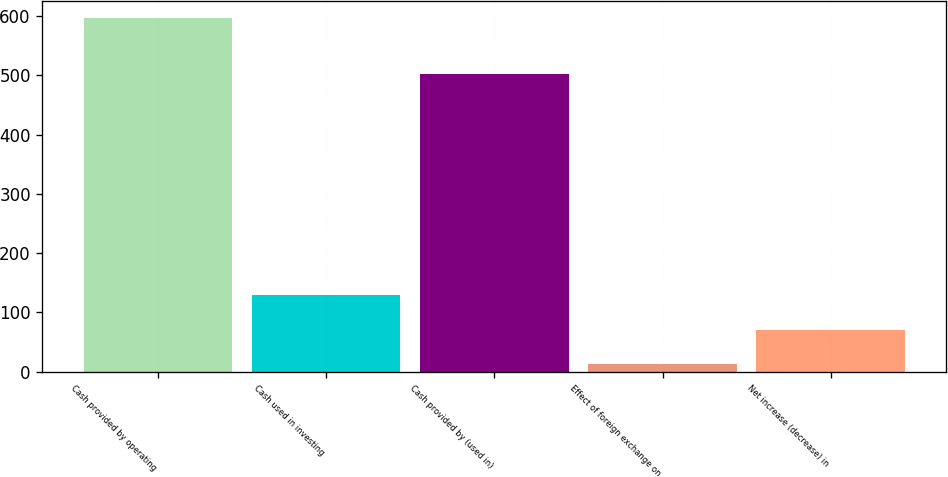Convert chart to OTSL. <chart><loc_0><loc_0><loc_500><loc_500><bar_chart><fcel>Cash provided by operating<fcel>Cash used in investing<fcel>Cash provided by (used in)<fcel>Effect of foreign exchange on<fcel>Net increase (decrease) in<nl><fcel>596<fcel>129.6<fcel>503<fcel>13<fcel>71.3<nl></chart> 